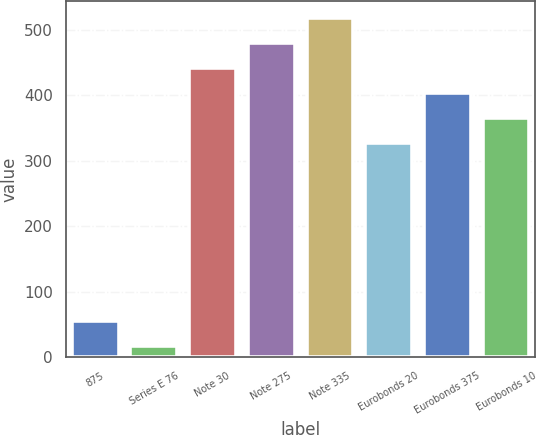<chart> <loc_0><loc_0><loc_500><loc_500><bar_chart><fcel>875<fcel>Series E 76<fcel>Note 30<fcel>Note 275<fcel>Note 335<fcel>Eurobonds 20<fcel>Eurobonds 375<fcel>Eurobonds 10<nl><fcel>55.48<fcel>17.2<fcel>441.84<fcel>480.12<fcel>518.4<fcel>327<fcel>403.56<fcel>365.28<nl></chart> 